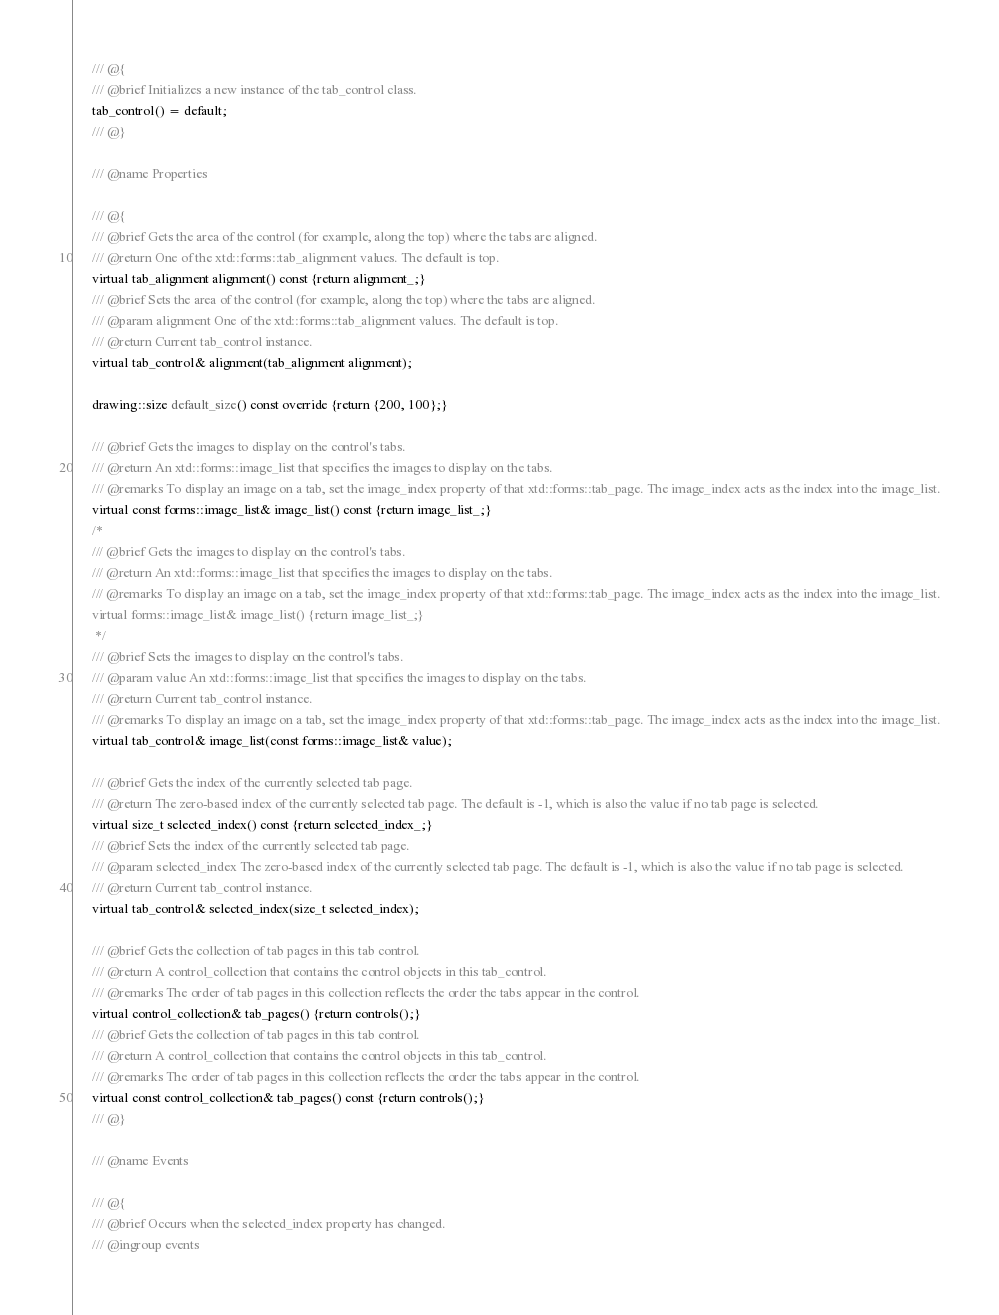Convert code to text. <code><loc_0><loc_0><loc_500><loc_500><_C_>      /// @{
      /// @brief Initializes a new instance of the tab_control class.
      tab_control() = default;
      /// @}
      
      /// @name Properties
      
      /// @{
      /// @brief Gets the area of the control (for example, along the top) where the tabs are aligned.
      /// @return One of the xtd::forms::tab_alignment values. The default is top.
      virtual tab_alignment alignment() const {return alignment_;}
      /// @brief Sets the area of the control (for example, along the top) where the tabs are aligned.
      /// @param alignment One of the xtd::forms::tab_alignment values. The default is top.
      /// @return Current tab_control instance.
      virtual tab_control& alignment(tab_alignment alignment);
      
      drawing::size default_size() const override {return {200, 100};}
      
      /// @brief Gets the images to display on the control's tabs.
      /// @return An xtd::forms::image_list that specifies the images to display on the tabs.
      /// @remarks To display an image on a tab, set the image_index property of that xtd::forms::tab_page. The image_index acts as the index into the image_list.
      virtual const forms::image_list& image_list() const {return image_list_;}
      /*
      /// @brief Gets the images to display on the control's tabs.
      /// @return An xtd::forms::image_list that specifies the images to display on the tabs.
      /// @remarks To display an image on a tab, set the image_index property of that xtd::forms::tab_page. The image_index acts as the index into the image_list.
      virtual forms::image_list& image_list() {return image_list_;}
       */
      /// @brief Sets the images to display on the control's tabs.
      /// @param value An xtd::forms::image_list that specifies the images to display on the tabs.
      /// @return Current tab_control instance.
      /// @remarks To display an image on a tab, set the image_index property of that xtd::forms::tab_page. The image_index acts as the index into the image_list.
      virtual tab_control& image_list(const forms::image_list& value);
      
      /// @brief Gets the index of the currently selected tab page.
      /// @return The zero-based index of the currently selected tab page. The default is -1, which is also the value if no tab page is selected.
      virtual size_t selected_index() const {return selected_index_;}
      /// @brief Sets the index of the currently selected tab page.
      /// @param selected_index The zero-based index of the currently selected tab page. The default is -1, which is also the value if no tab page is selected.
      /// @return Current tab_control instance.
      virtual tab_control& selected_index(size_t selected_index);
      
      /// @brief Gets the collection of tab pages in this tab control.
      /// @return A control_collection that contains the control objects in this tab_control.
      /// @remarks The order of tab pages in this collection reflects the order the tabs appear in the control.
      virtual control_collection& tab_pages() {return controls();}
      /// @brief Gets the collection of tab pages in this tab control.
      /// @return A control_collection that contains the control objects in this tab_control.
      /// @remarks The order of tab pages in this collection reflects the order the tabs appear in the control.
      virtual const control_collection& tab_pages() const {return controls();}
      /// @}
      
      /// @name Events
      
      /// @{
      /// @brief Occurs when the selected_index property has changed.
      /// @ingroup events</code> 